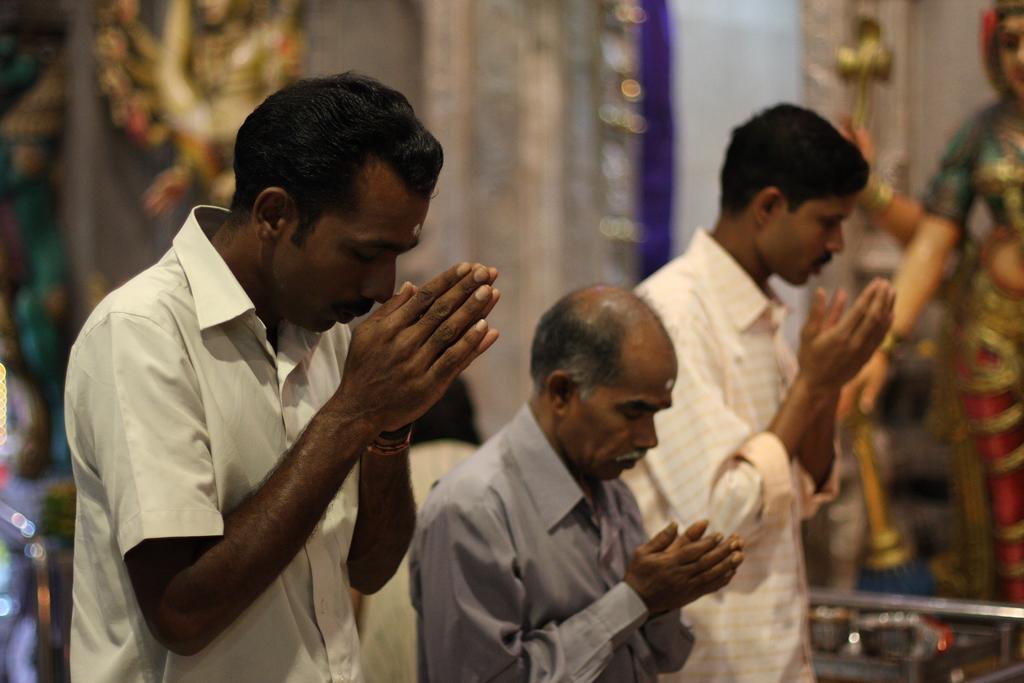In one or two sentences, can you explain what this image depicts? In the image there are three men praying to the god and in the back there are god idols in front of the wall. 